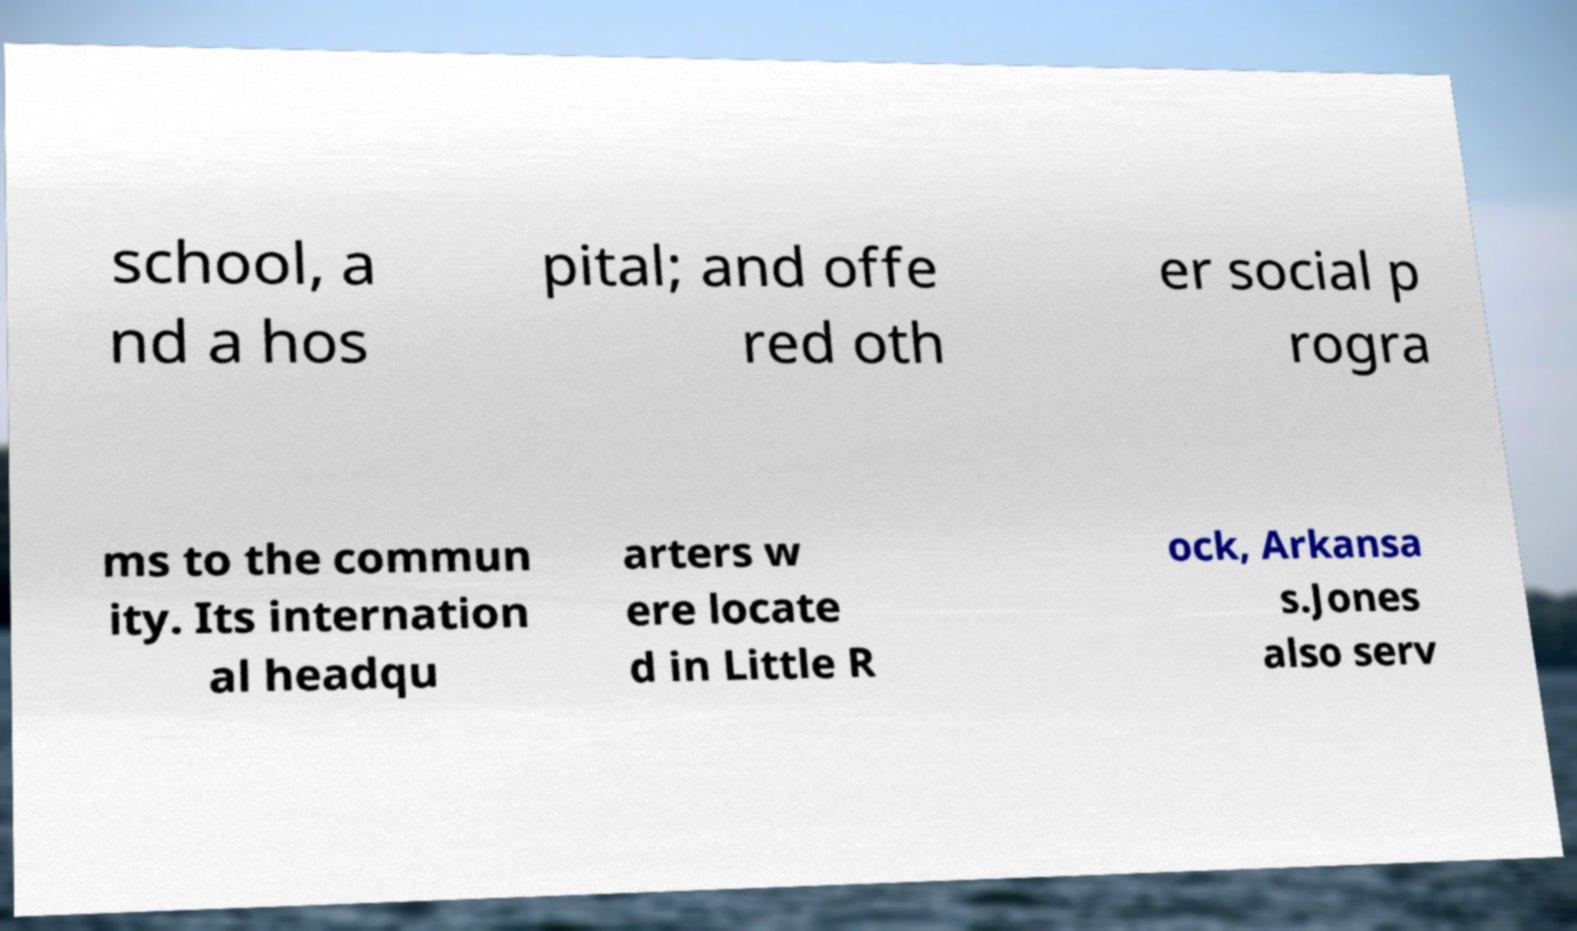Could you assist in decoding the text presented in this image and type it out clearly? school, a nd a hos pital; and offe red oth er social p rogra ms to the commun ity. Its internation al headqu arters w ere locate d in Little R ock, Arkansa s.Jones also serv 